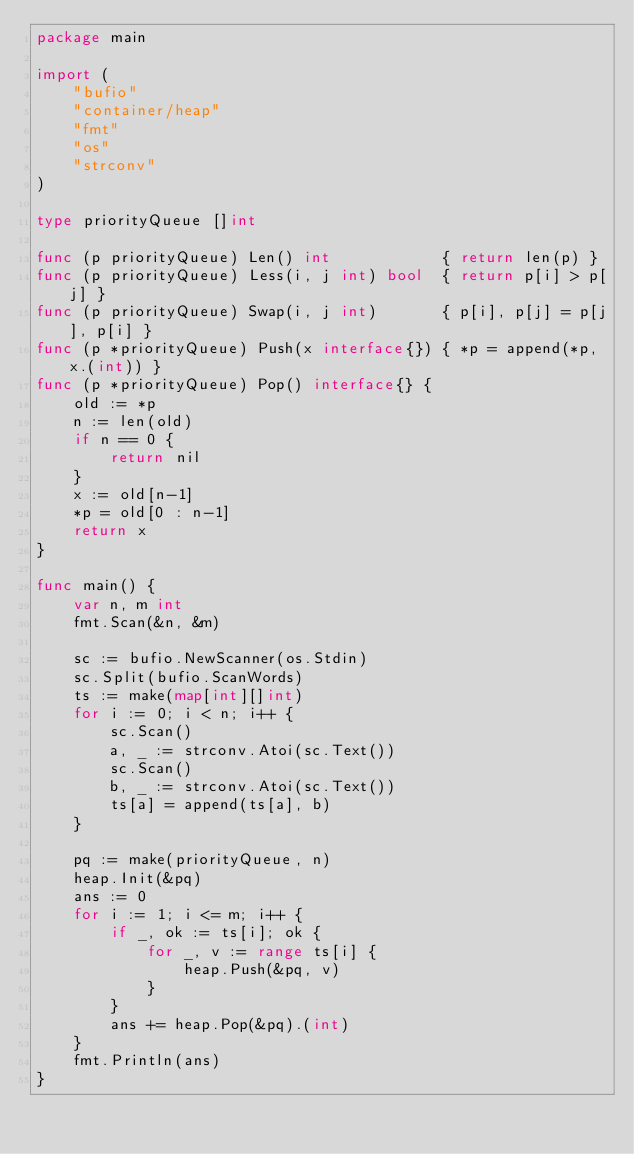<code> <loc_0><loc_0><loc_500><loc_500><_Go_>package main

import (
	"bufio"
	"container/heap"
	"fmt"
	"os"
	"strconv"
)

type priorityQueue []int

func (p priorityQueue) Len() int            { return len(p) }
func (p priorityQueue) Less(i, j int) bool  { return p[i] > p[j] }
func (p priorityQueue) Swap(i, j int)       { p[i], p[j] = p[j], p[i] }
func (p *priorityQueue) Push(x interface{}) { *p = append(*p, x.(int)) }
func (p *priorityQueue) Pop() interface{} {
	old := *p
	n := len(old)
	if n == 0 {
		return nil
	}
	x := old[n-1]
	*p = old[0 : n-1]
	return x
}

func main() {
	var n, m int
	fmt.Scan(&n, &m)

	sc := bufio.NewScanner(os.Stdin)
	sc.Split(bufio.ScanWords)
	ts := make(map[int][]int)
	for i := 0; i < n; i++ {
		sc.Scan()
		a, _ := strconv.Atoi(sc.Text())
		sc.Scan()
		b, _ := strconv.Atoi(sc.Text())
		ts[a] = append(ts[a], b)
	}

	pq := make(priorityQueue, n)
	heap.Init(&pq)
	ans := 0
	for i := 1; i <= m; i++ {
		if _, ok := ts[i]; ok {
			for _, v := range ts[i] {
				heap.Push(&pq, v)
			}
		}
		ans += heap.Pop(&pq).(int)
	}
	fmt.Println(ans)
}
</code> 